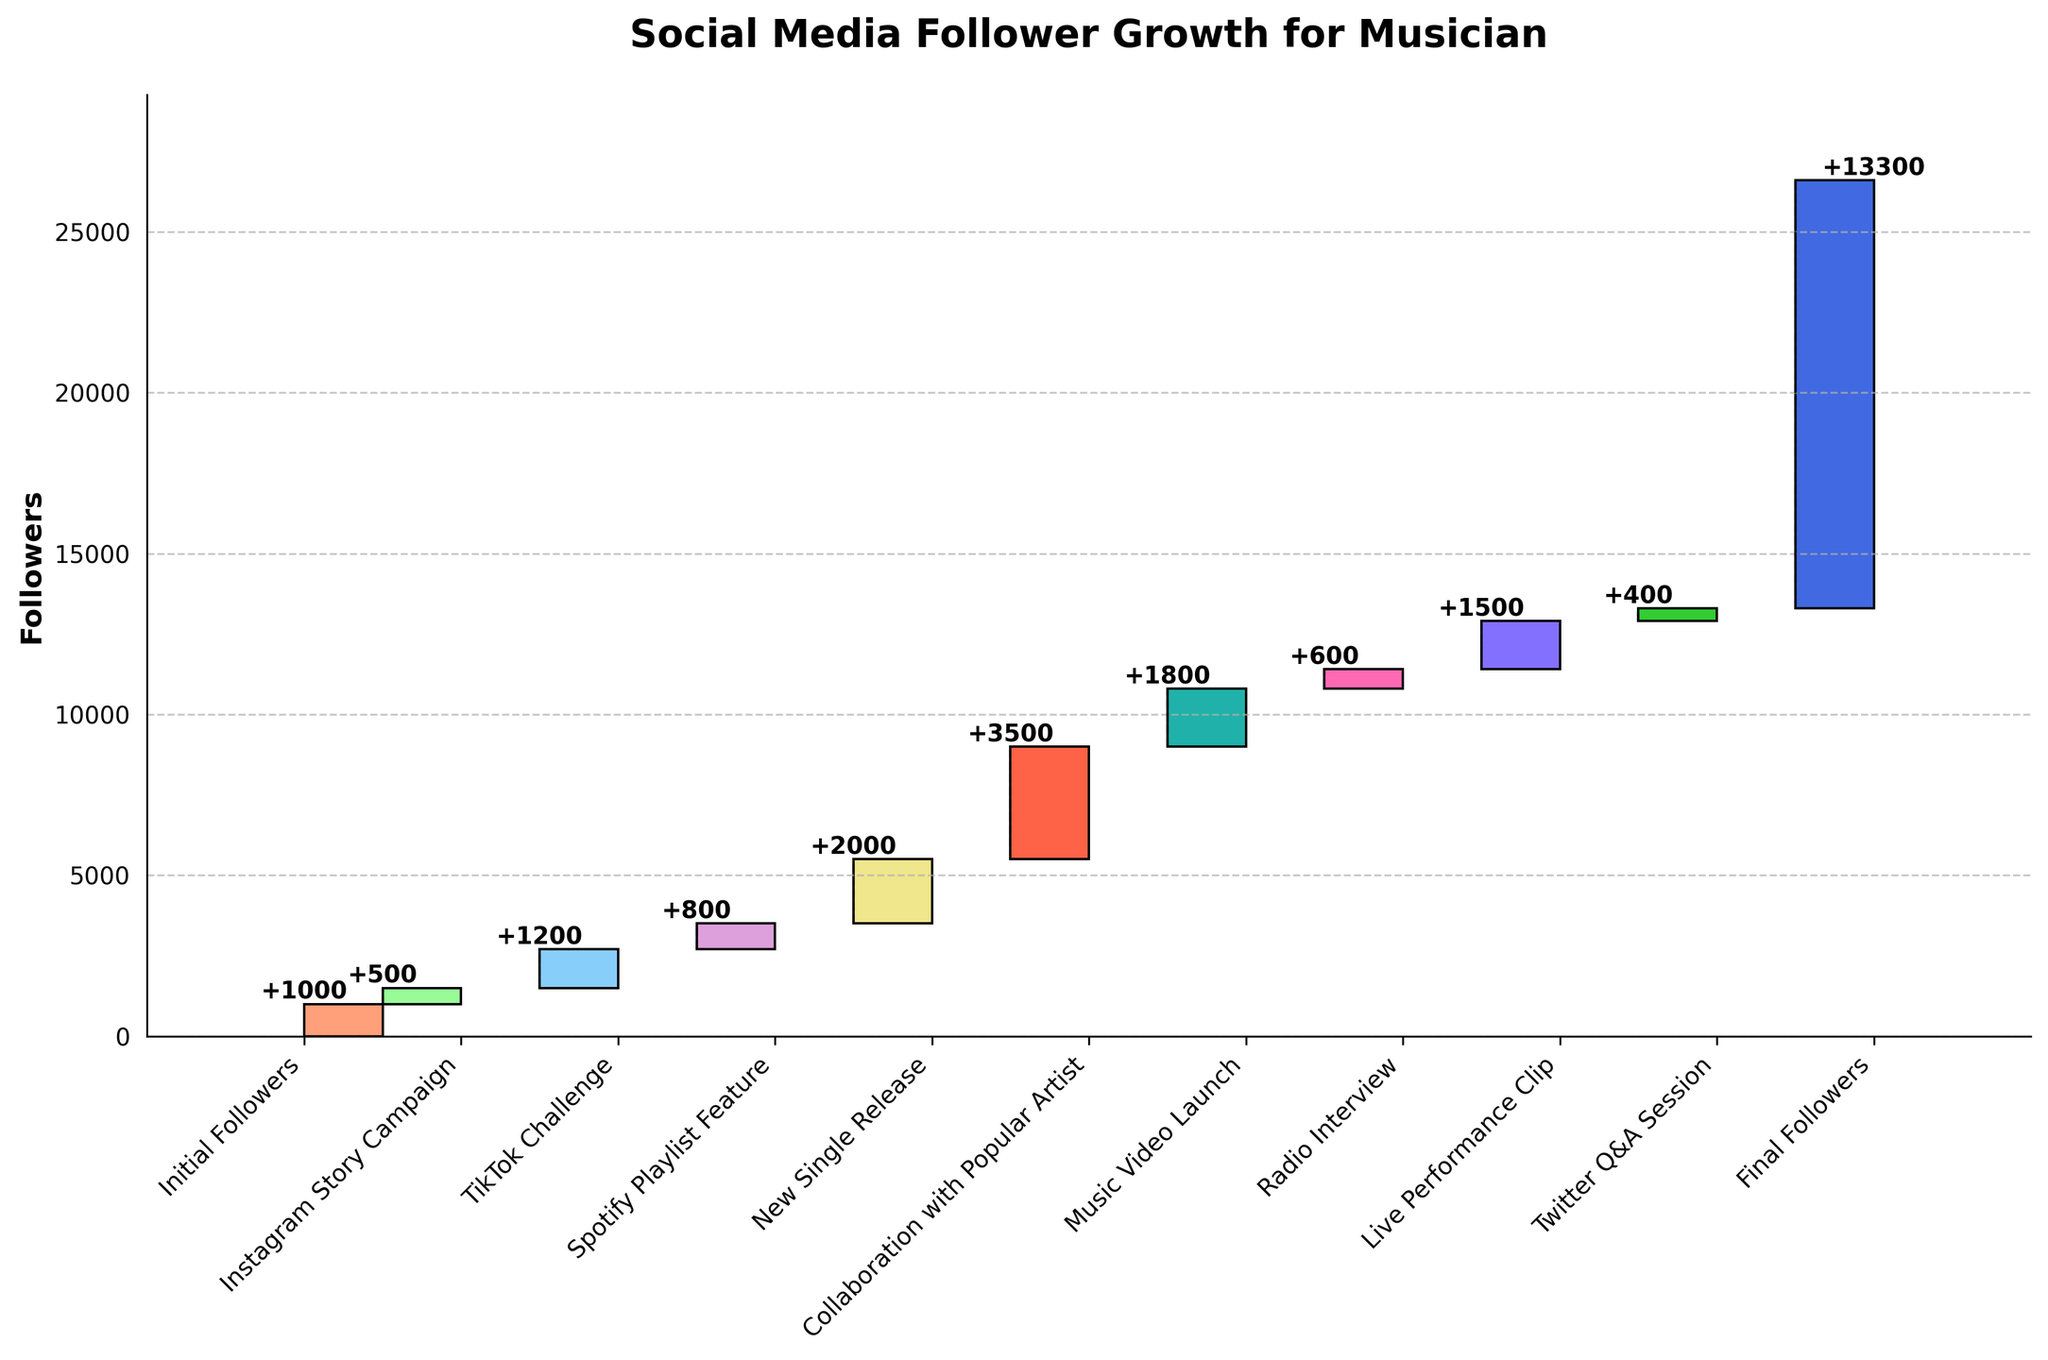Which category contributed the most followers? The figure shows that 'Collaboration with Popular Artist' added the most followers. By referring to the incremental increases, the 'Collaboration with Popular Artist' category added 3,500 followers, which is the highest among all categories.
Answer: Collaboration with Popular Artist How many followers were there after the 'Spotify Playlist Feature'? To find the total followers after 'Spotify Playlist Feature', we sum up the initial followers and the increments up to this point. This includes 1,000 (Initial Followers) + 500 (Instagram Story Campaign) + 1,200 (TikTok Challenge) + 800 (Spotify Playlist Feature) = 3,500 followers.
Answer: 3,500 What is the final total number of followers? The final total number of followers is indicated at the end of the waterfall chart, which is the sum of all the initial and incremental followers. The final number shown on the chart is 13,300.
Answer: 13,300 What is the sum of the followers gained from 'New Single Release' and 'Live Performance Clip' campaigns? To find this, we need to add the followers gained from both categories. The 'New Single Release' contributed 2,000 followers and the 'Live Performance Clip' contributed 1,500 followers, so the sum is 2,000 + 1,500 = 3,500 followers.
Answer: 3,500 Which category had the smallest increase in followers? By comparing the incremental increases shown in the plot, the category 'Twitter Q&A Session' had the smallest increase in followers, with an increment of 400 followers.
Answer: Twitter Q&A Session How many followers were added from the marketing campaigns alone (excluding song releases and media features)? To find this, sum up the increments from the campaigns: 500 (Instagram Story Campaign) + 1,200 (TikTok Challenge) + 600 (Radio Interview) + 1,500 (Live Performance Clip) + 400 (Twitter Q&A Session) = 4,200 followers.
Answer: 4,200 What is the increase in followers after 'New Single Release' compared to after 'TikTok Challenge'? To find this, first calculate followers after 'New Single Release' (previous total plus increments including this step): 1,000 (Initial Followers) + 500 (Instagram Story Campaign) + 1,200 (TikTok Challenge) + 800 (Spotify Playlist Feature) + 2,000 (New Single Release) = 5,500 followers. Now, the followers after 'TikTok Challenge' are 1,000 + 500 + 1,200 = 2,700 followers. The increase is 5,500 - 2,700 = 2,800 followers.
Answer: 2,800 After which category did the total follower count exceed 10,000? By looking at the cumulative totals, we find that after the 'Collaboration with Popular Artist', the total followers exceeded 10,000. Adding up: 1,000 (Initial Followers) + 500 (Instagram Story Campaign) + 1,200 (TikTok Challenge) + 800 (Spotify Playlist Feature) + 2,000 (New Single Release) + 3,500 (Collaboration with Popular Artist) = 9,000 followers.
Answer: Collaboration with Popular Artist What was the total followers count right before the 'Music Video Launch'? Before the 'Music Video Launch', the cumulative sum includes all previous increments. Based on the chart, it’s: 1,000 + 500 + 1,200 + 800 + 2,000 + 3,500 = 9,000 followers.
Answer: 9,000 